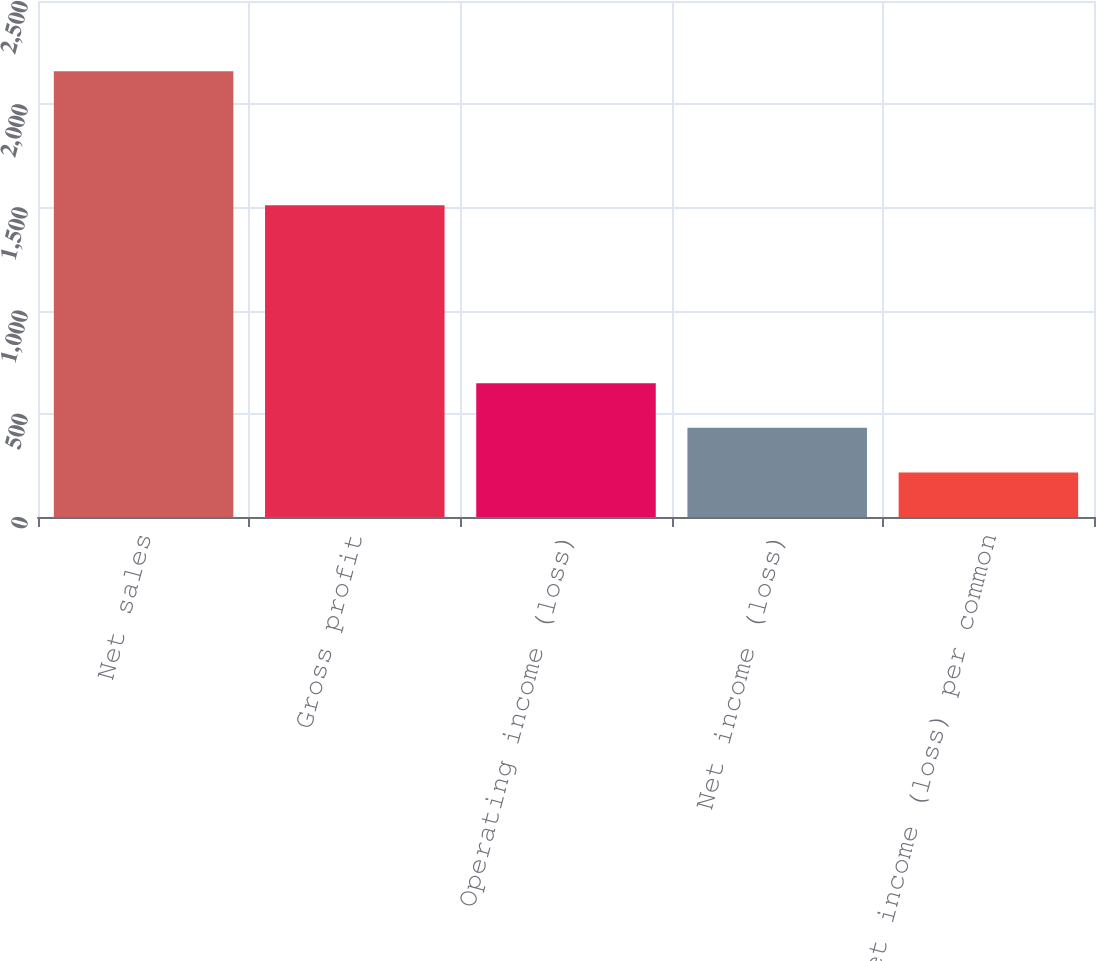<chart> <loc_0><loc_0><loc_500><loc_500><bar_chart><fcel>Net sales<fcel>Gross profit<fcel>Operating income (loss)<fcel>Net income (loss)<fcel>Net income (loss) per common<nl><fcel>2160<fcel>1510<fcel>648.15<fcel>432.17<fcel>216.19<nl></chart> 